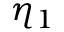Convert formula to latex. <formula><loc_0><loc_0><loc_500><loc_500>\eta _ { 1 }</formula> 